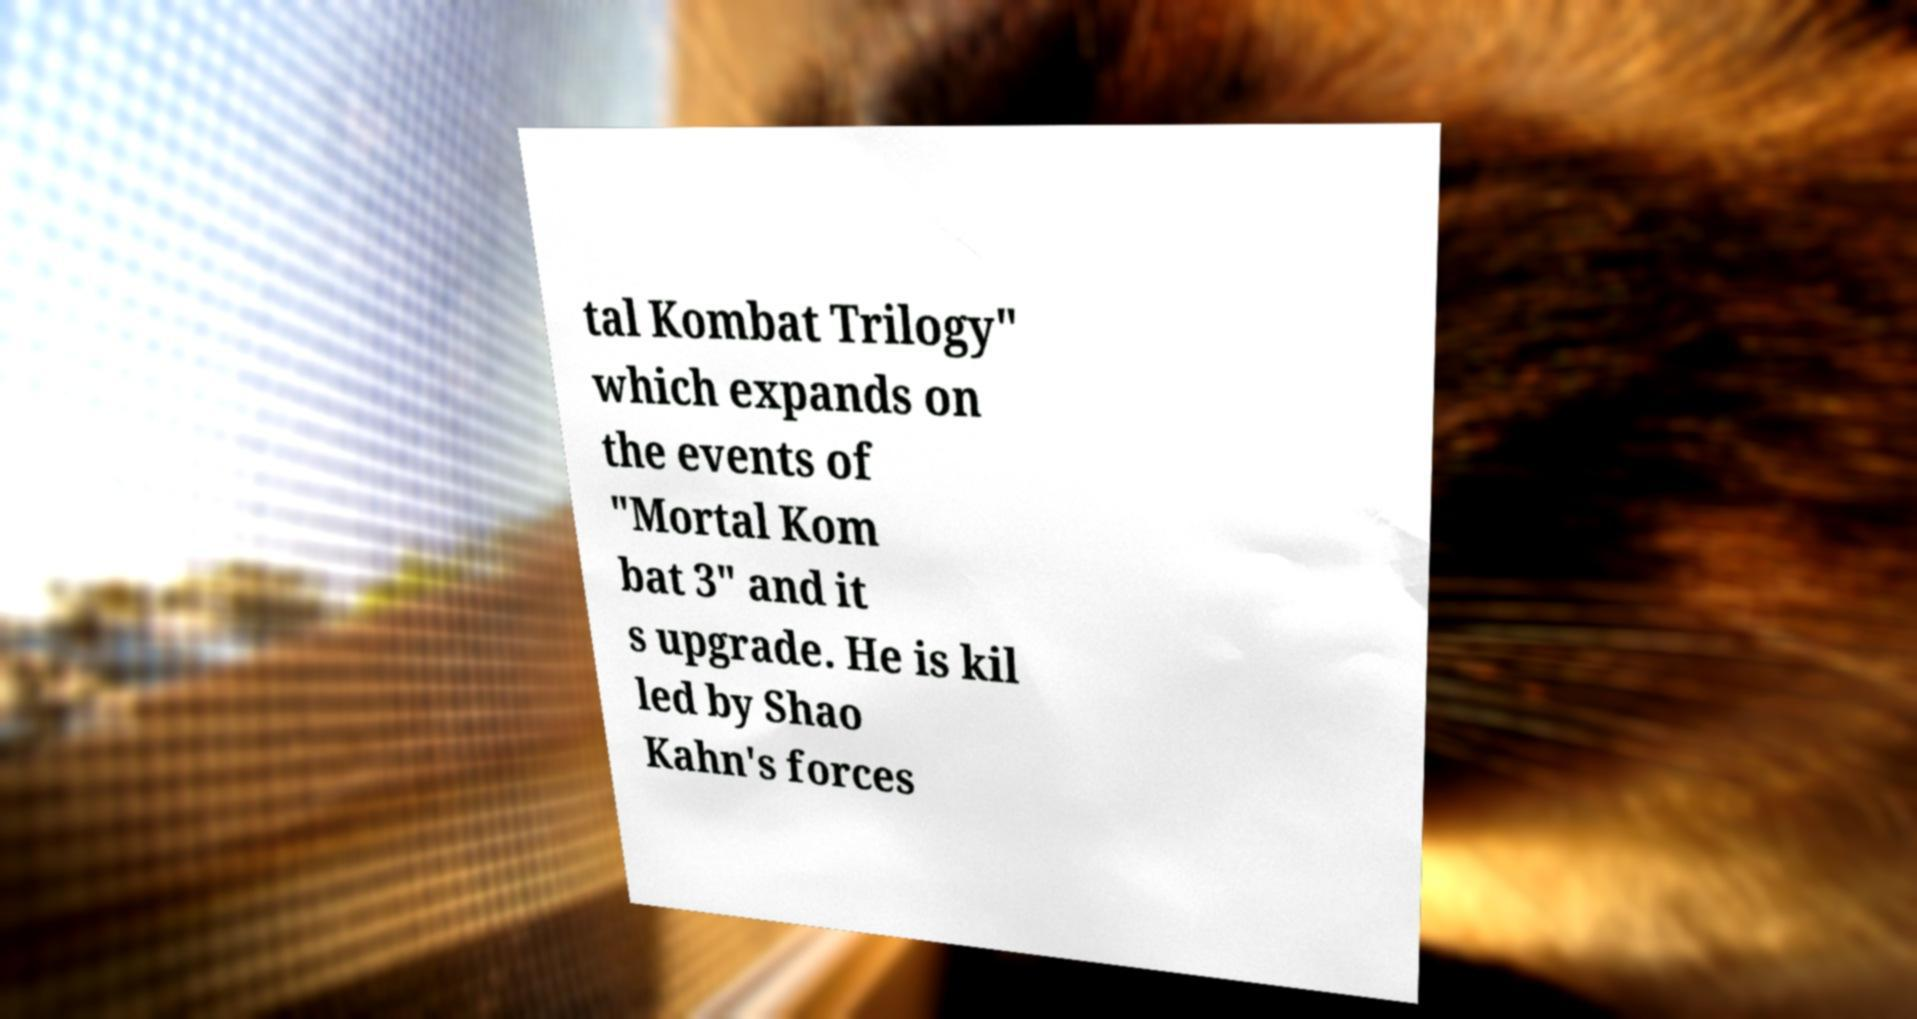Can you accurately transcribe the text from the provided image for me? tal Kombat Trilogy" which expands on the events of "Mortal Kom bat 3" and it s upgrade. He is kil led by Shao Kahn's forces 